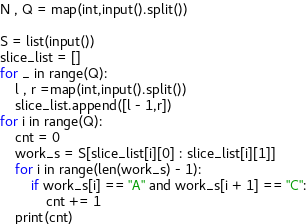<code> <loc_0><loc_0><loc_500><loc_500><_Python_>N , Q = map(int,input().split())

S = list(input())
slice_list = []
for _ in range(Q):
    l , r =map(int,input().split())
    slice_list.append([l - 1,r])
for i in range(Q):
    cnt = 0
    work_s = S[slice_list[i][0] : slice_list[i][1]]
    for i in range(len(work_s) - 1):
        if work_s[i] == "A" and work_s[i + 1] == "C":
            cnt += 1
    print(cnt)</code> 